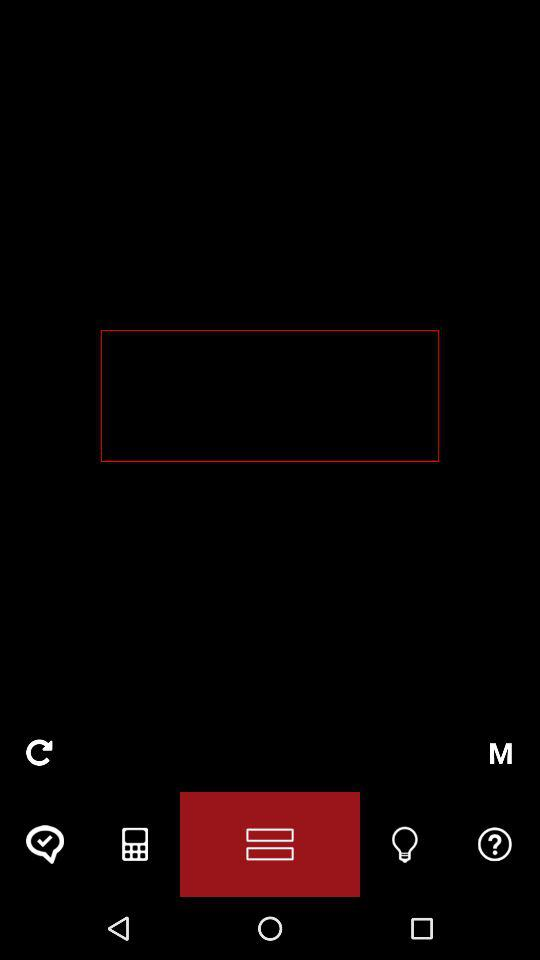Which button is to be tapped to change focus, math and output mode for the situation? The button to change focus, math and output mode for the situation is "M". 